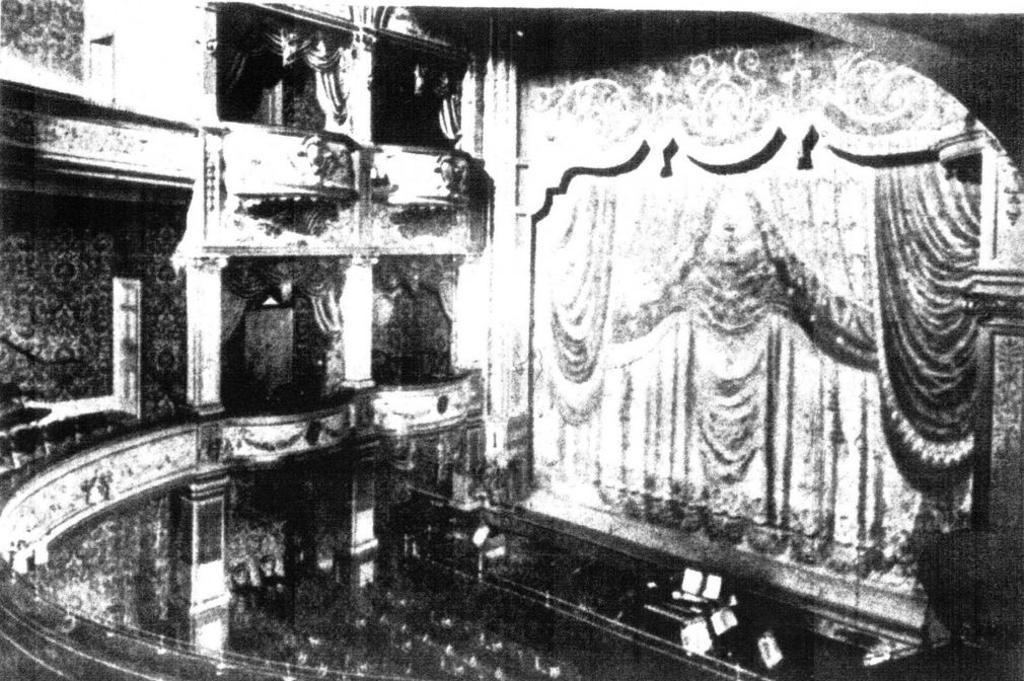Could you give a brief overview of what you see in this image? This is an old black and white image. I think this picture was taken inside the building. These look like the curtains hanging. I can see the pillars. I think this is a stage. 